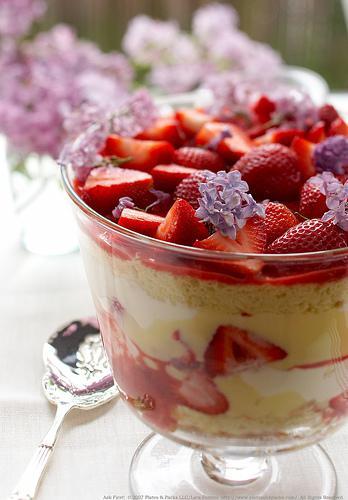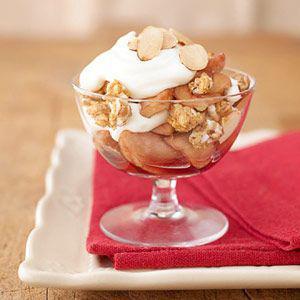The first image is the image on the left, the second image is the image on the right. Assess this claim about the two images: "One image shows a layered dessert garnished with blueberries, and all desserts shown in left and right images are garnished with some type of berry.". Correct or not? Answer yes or no. No. The first image is the image on the left, the second image is the image on the right. Assess this claim about the two images: "One of the images contains a lemon in the background on the table.". Correct or not? Answer yes or no. No. 